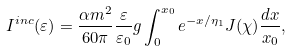Convert formula to latex. <formula><loc_0><loc_0><loc_500><loc_500>I ^ { i n c } ( \varepsilon ) = \frac { \alpha m ^ { 2 } } { 6 0 \pi } \frac { \varepsilon } { \varepsilon _ { 0 } } g \int _ { 0 } ^ { x _ { 0 } } e ^ { - x / \eta _ { 1 } } J ( \chi ) \frac { d x } { x _ { 0 } } ,</formula> 